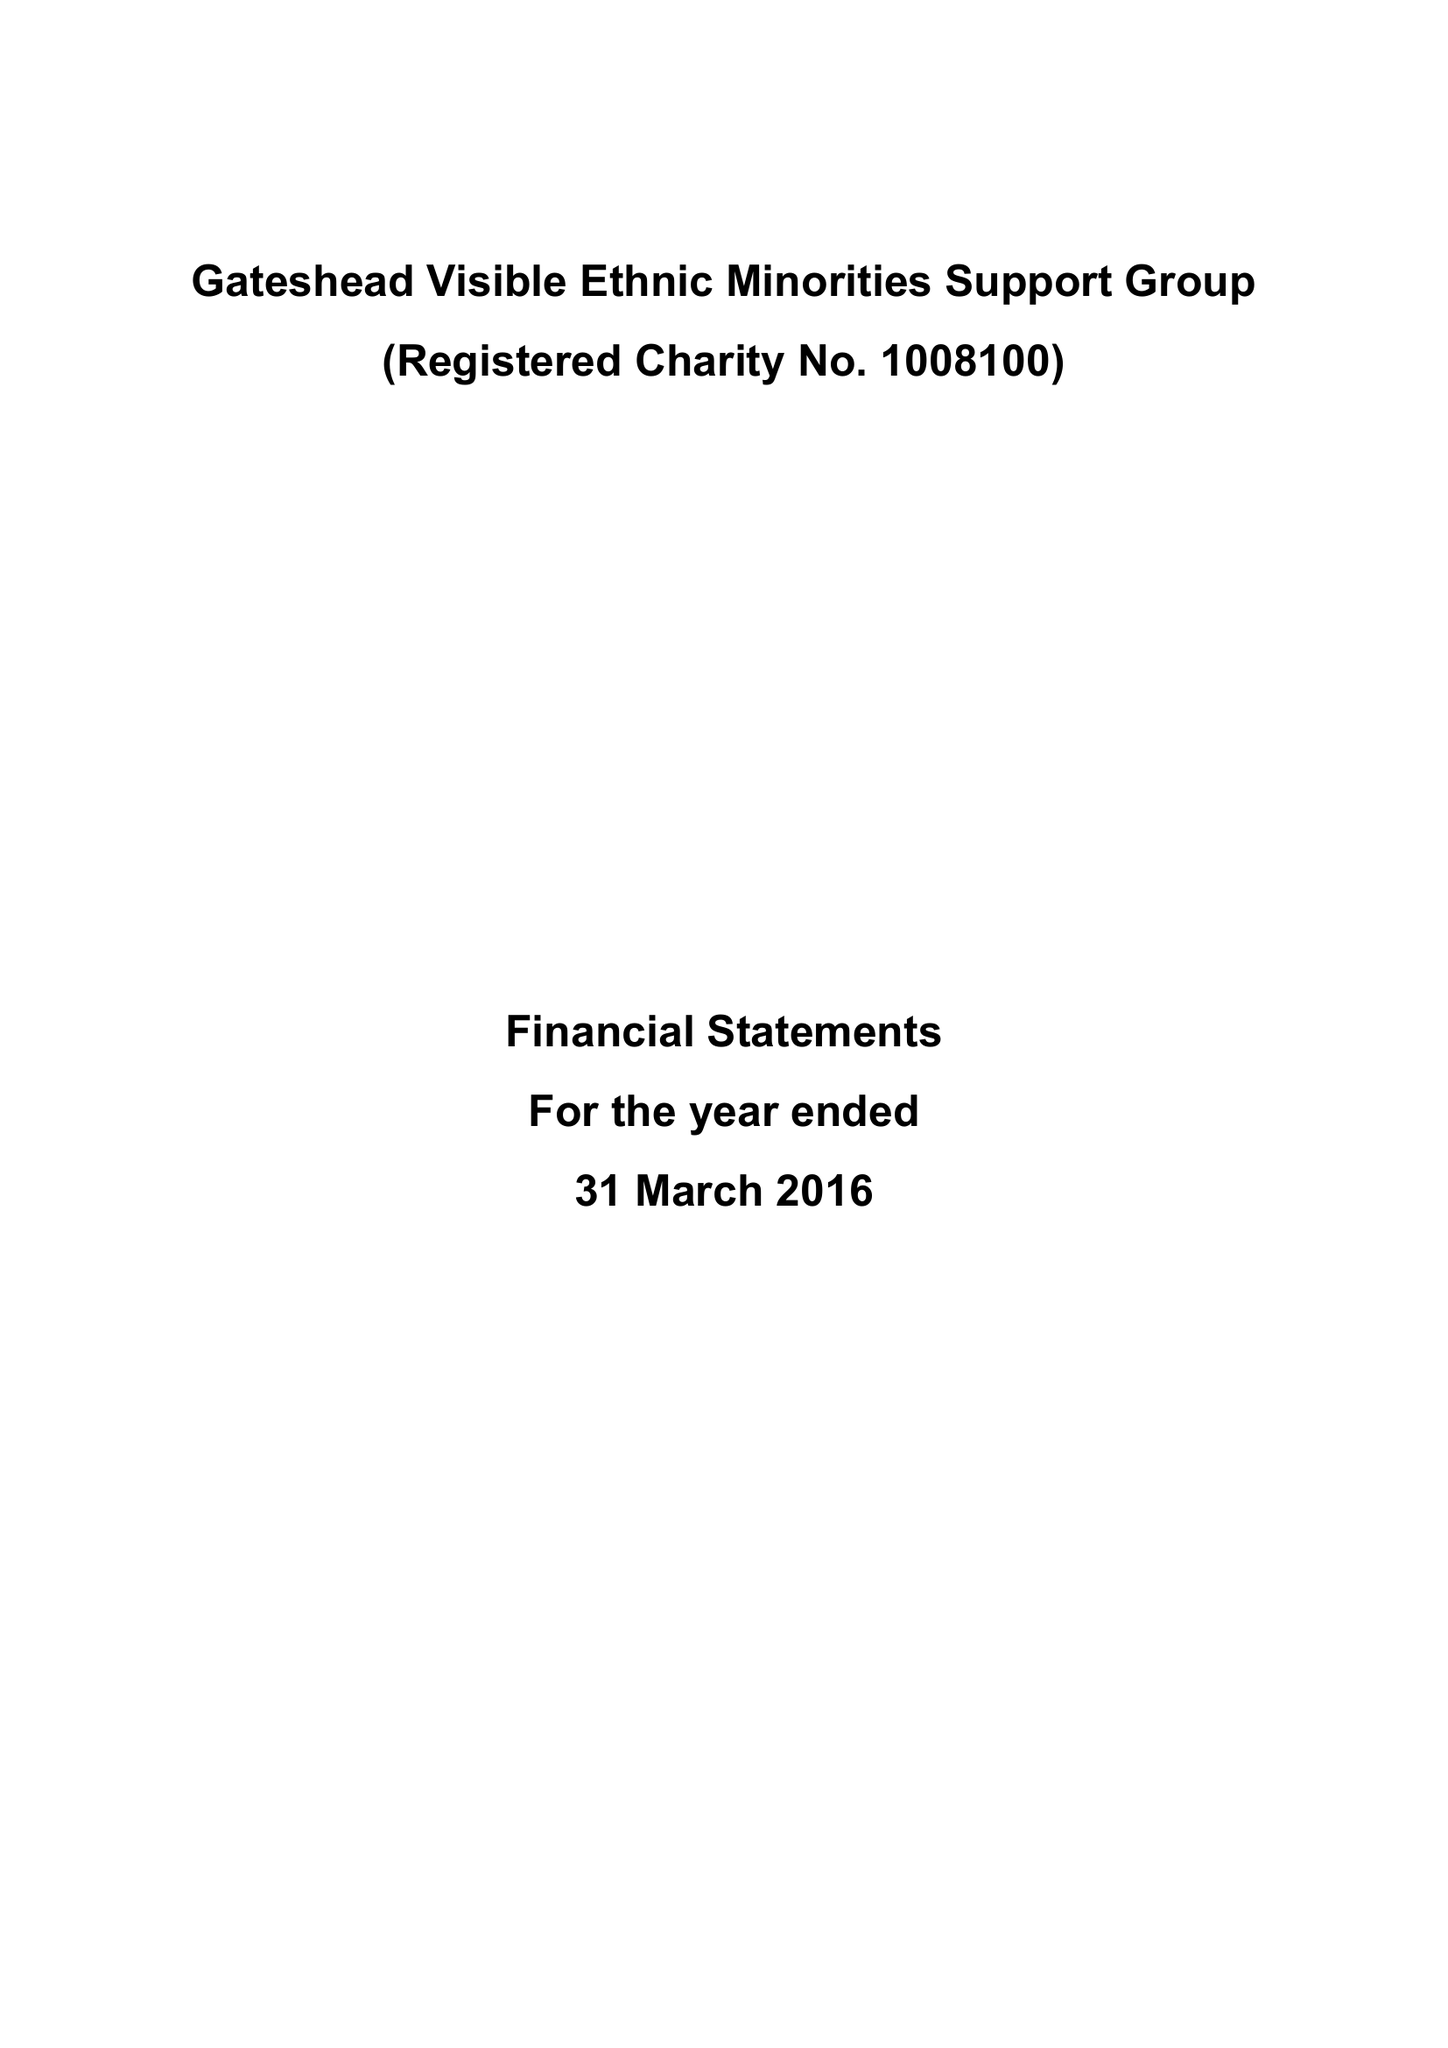What is the value for the address__post_town?
Answer the question using a single word or phrase. GATESHEAD 